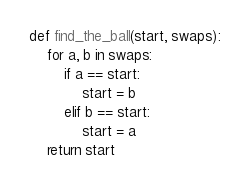Convert code to text. <code><loc_0><loc_0><loc_500><loc_500><_Python_>def find_the_ball(start, swaps):
    for a, b in swaps:
        if a == start:
            start = b
        elif b == start:
            start = a
    return start
</code> 